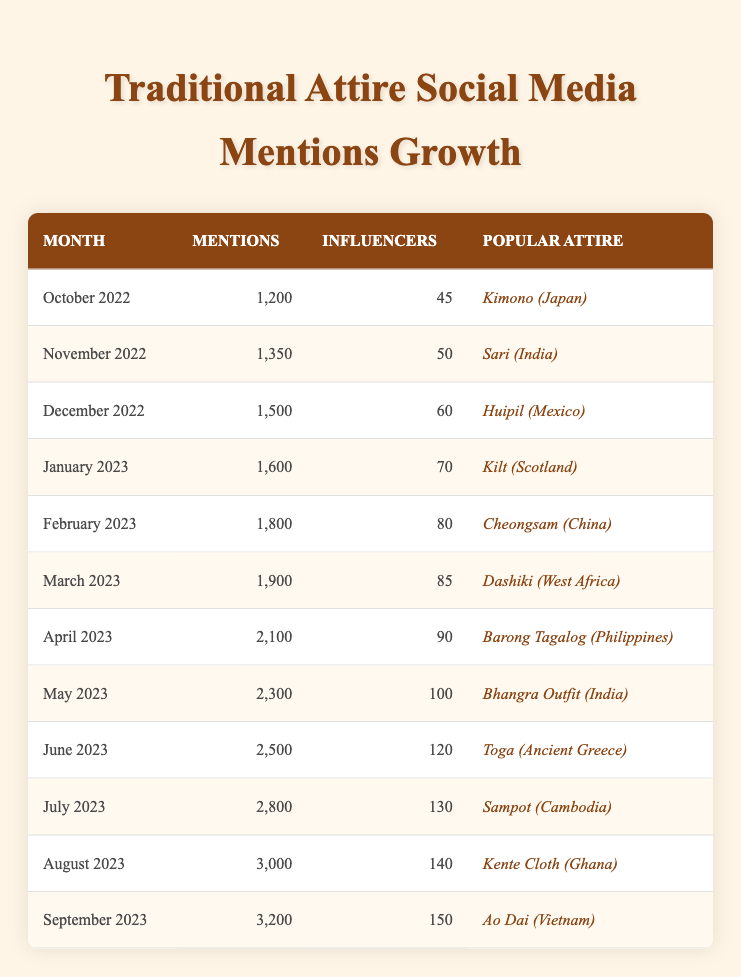What is the most popular traditional attire mentioned in the table? The most popular traditional attire mentioned in the table is "Ao Dai (Vietnam)" in September 2023, as it is the last entry and is notable for its cultural significance.
Answer: Ao Dai (Vietnam) Which month had the highest number of mentions? The month with the highest number of mentions is September 2023, with 3,200 mentions, which can be found in the last row of the table.
Answer: September 2023 How many influencers mentioned traditional attire in May 2023? In May 2023, there were 100 influencers who mentioned traditional attire, as indicated in the relevant row of the table.
Answer: 100 Calculate the growth in mentions from October 2022 to August 2023. The mentions in October 2022 were 1,200, and in August 2023 they were 3,000. The growth is 3,000 - 1,200 = 1,800 mentions.
Answer: 1800 Did the mentions in April 2023 exceed those in January 2023? Yes, in April 2023 there were 2,100 mentions while in January 2023 there were only 1,600 mentions, indicating an increase.
Answer: Yes What is the average number of mentions for the six months from March 2023 to August 2023? The months from March (1,900) to August (3,000) have the following mentions: 1,900, 2,100, 2,300, 2,500, 2,800, and 3,000. The average is (1,900 + 2,100 + 2,300 + 2,500 + 2,800 + 3,000) / 6 = 2,266.67, rounded gives approximately 2267 mentions.
Answer: 2267 Which traditional attire saw an increase in mentions every month from October 2022 to September 2023? All traditional attires mentioned saw an increase in mentions each month, as shown in the table with consistently rising numbers for every month.
Answer: Yes What was the total number of mentions across all months listed in the table? The total number of mentions is the sum of mentions from each month: 1,200 + 1,350 + 1,500 + 1,600 + 1,800 + 1,900 + 2,100 + 2,300 + 2,500 + 2,800 + 3,000 + 3,200 = 23,650.
Answer: 23650 How many months had more than 2,500 mentions? The months with more than 2,500 mentions are June (2,500), July (2,800), August (3,000), and September (3,200). That makes a total of 4 months.
Answer: 4 